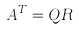Convert formula to latex. <formula><loc_0><loc_0><loc_500><loc_500>A ^ { T } = Q R</formula> 